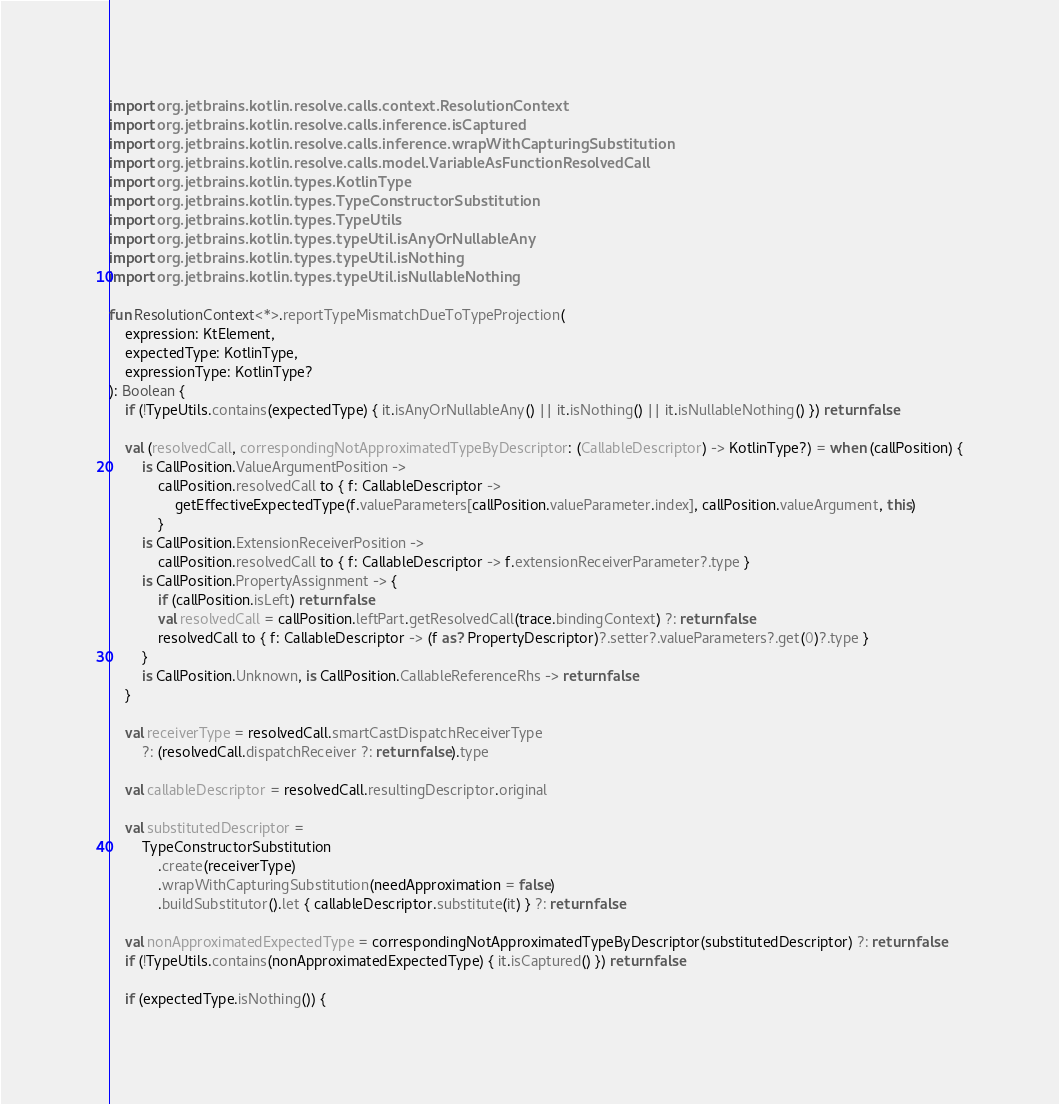<code> <loc_0><loc_0><loc_500><loc_500><_Kotlin_>import org.jetbrains.kotlin.resolve.calls.context.ResolutionContext
import org.jetbrains.kotlin.resolve.calls.inference.isCaptured
import org.jetbrains.kotlin.resolve.calls.inference.wrapWithCapturingSubstitution
import org.jetbrains.kotlin.resolve.calls.model.VariableAsFunctionResolvedCall
import org.jetbrains.kotlin.types.KotlinType
import org.jetbrains.kotlin.types.TypeConstructorSubstitution
import org.jetbrains.kotlin.types.TypeUtils
import org.jetbrains.kotlin.types.typeUtil.isAnyOrNullableAny
import org.jetbrains.kotlin.types.typeUtil.isNothing
import org.jetbrains.kotlin.types.typeUtil.isNullableNothing

fun ResolutionContext<*>.reportTypeMismatchDueToTypeProjection(
    expression: KtElement,
    expectedType: KotlinType,
    expressionType: KotlinType?
): Boolean {
    if (!TypeUtils.contains(expectedType) { it.isAnyOrNullableAny() || it.isNothing() || it.isNullableNothing() }) return false

    val (resolvedCall, correspondingNotApproximatedTypeByDescriptor: (CallableDescriptor) -> KotlinType?) = when (callPosition) {
        is CallPosition.ValueArgumentPosition ->
            callPosition.resolvedCall to { f: CallableDescriptor ->
                getEffectiveExpectedType(f.valueParameters[callPosition.valueParameter.index], callPosition.valueArgument, this)
            }
        is CallPosition.ExtensionReceiverPosition ->
            callPosition.resolvedCall to { f: CallableDescriptor -> f.extensionReceiverParameter?.type }
        is CallPosition.PropertyAssignment -> {
            if (callPosition.isLeft) return false
            val resolvedCall = callPosition.leftPart.getResolvedCall(trace.bindingContext) ?: return false
            resolvedCall to { f: CallableDescriptor -> (f as? PropertyDescriptor)?.setter?.valueParameters?.get(0)?.type }
        }
        is CallPosition.Unknown, is CallPosition.CallableReferenceRhs -> return false
    }

    val receiverType = resolvedCall.smartCastDispatchReceiverType
        ?: (resolvedCall.dispatchReceiver ?: return false).type

    val callableDescriptor = resolvedCall.resultingDescriptor.original

    val substitutedDescriptor =
        TypeConstructorSubstitution
            .create(receiverType)
            .wrapWithCapturingSubstitution(needApproximation = false)
            .buildSubstitutor().let { callableDescriptor.substitute(it) } ?: return false

    val nonApproximatedExpectedType = correspondingNotApproximatedTypeByDescriptor(substitutedDescriptor) ?: return false
    if (!TypeUtils.contains(nonApproximatedExpectedType) { it.isCaptured() }) return false

    if (expectedType.isNothing()) {</code> 